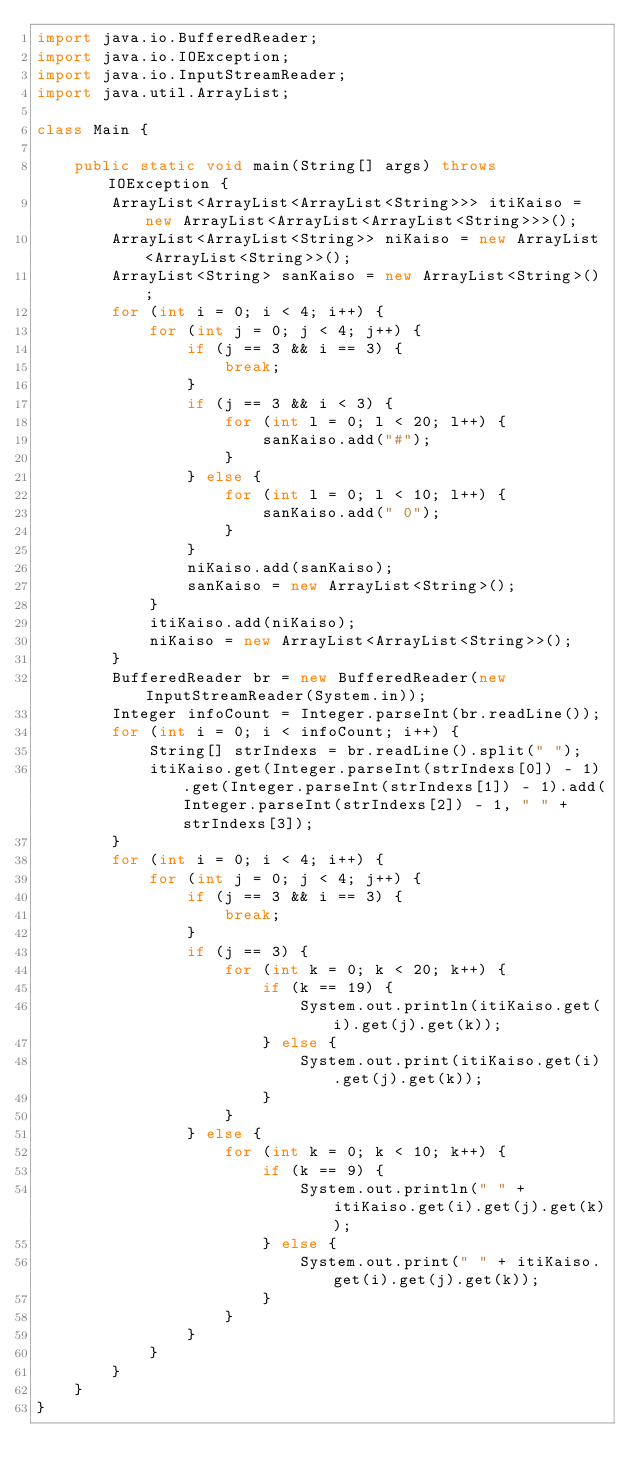<code> <loc_0><loc_0><loc_500><loc_500><_Java_>import java.io.BufferedReader;
import java.io.IOException;
import java.io.InputStreamReader;
import java.util.ArrayList;

class Main {

	public static void main(String[] args) throws IOException {
		ArrayList<ArrayList<ArrayList<String>>> itiKaiso = new ArrayList<ArrayList<ArrayList<String>>>();
		ArrayList<ArrayList<String>> niKaiso = new ArrayList<ArrayList<String>>();
		ArrayList<String> sanKaiso = new ArrayList<String>();
		for (int i = 0; i < 4; i++) {
			for (int j = 0; j < 4; j++) {
				if (j == 3 && i == 3) {
					break;
				}
				if (j == 3 && i < 3) {
					for (int l = 0; l < 20; l++) {
						sanKaiso.add("#");
					}
				} else {
					for (int l = 0; l < 10; l++) {
						sanKaiso.add(" 0");
					}
				}
				niKaiso.add(sanKaiso);
				sanKaiso = new ArrayList<String>();
			}
			itiKaiso.add(niKaiso);
			niKaiso = new ArrayList<ArrayList<String>>();
		}
		BufferedReader br = new BufferedReader(new InputStreamReader(System.in));
		Integer infoCount = Integer.parseInt(br.readLine());
		for (int i = 0; i < infoCount; i++) {
			String[] strIndexs = br.readLine().split(" ");
			itiKaiso.get(Integer.parseInt(strIndexs[0]) - 1).get(Integer.parseInt(strIndexs[1]) - 1).add(Integer.parseInt(strIndexs[2]) - 1, " " + strIndexs[3]);
		}
		for (int i = 0; i < 4; i++) {
			for (int j = 0; j < 4; j++) {
				if (j == 3 && i == 3) {
					break;
				}
				if (j == 3) {
					for (int k = 0; k < 20; k++) {
						if (k == 19) {
							System.out.println(itiKaiso.get(i).get(j).get(k));
						} else {
							System.out.print(itiKaiso.get(i).get(j).get(k));
						}
					}
				} else {
					for (int k = 0; k < 10; k++) {
						if (k == 9) {
							System.out.println(" " + itiKaiso.get(i).get(j).get(k));
						} else {
							System.out.print(" " + itiKaiso.get(i).get(j).get(k));
						}
					}
				}
			}
		}
	}
}</code> 